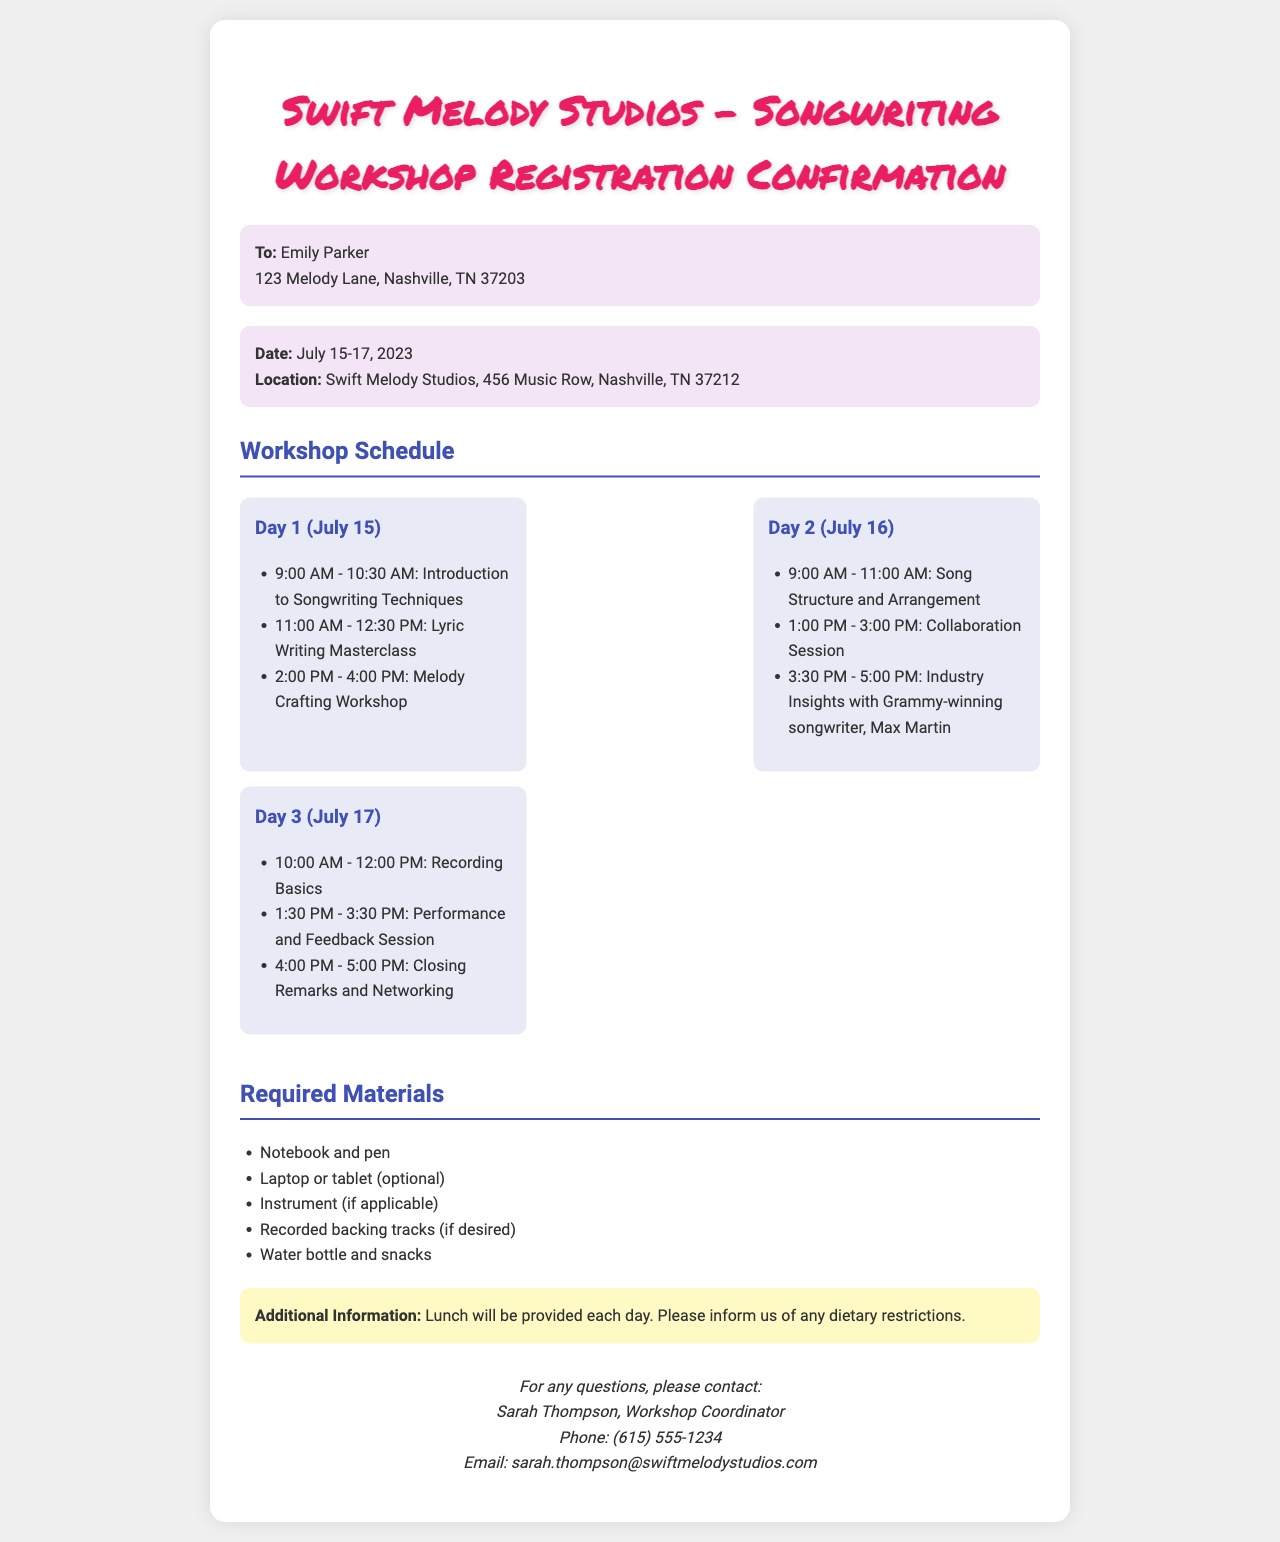What are the dates of the workshop? The dates of the workshop are specified in the document as July 15-17, 2023.
Answer: July 15-17, 2023 Who is the contact person for the workshop? The workshop coordinator is mentioned in the contact details as Sarah Thompson.
Answer: Sarah Thompson What time does the Introduction to Songwriting Techniques session start? The schedule indicates that this session starts at 9:00 AM on Day 1, July 15.
Answer: 9:00 AM What is required to bring to the workshop? The document lists required materials including a notebook and pen.
Answer: Notebook and pen How many workshops are scheduled on Day 2? By counting the listed activities for Day 2, there are three workshops scheduled.
Answer: Three Where is the location of the workshop? The document specifies the location of the workshop as Swift Melody Studios, 456 Music Row, Nashville, TN 37212.
Answer: Swift Melody Studios, 456 Music Row, Nashville, TN 37212 What time does the Closing Remarks and Networking session end? The schedule shows this session ends at 5:00 PM on Day 3, July 17.
Answer: 5:00 PM What type of meals are provided during the workshop? The additional information section states that lunch will be provided each day.
Answer: Lunch What kind of session is led by Max Martin? The schedule indicates that he leads an Industry Insights session.
Answer: Industry Insights 